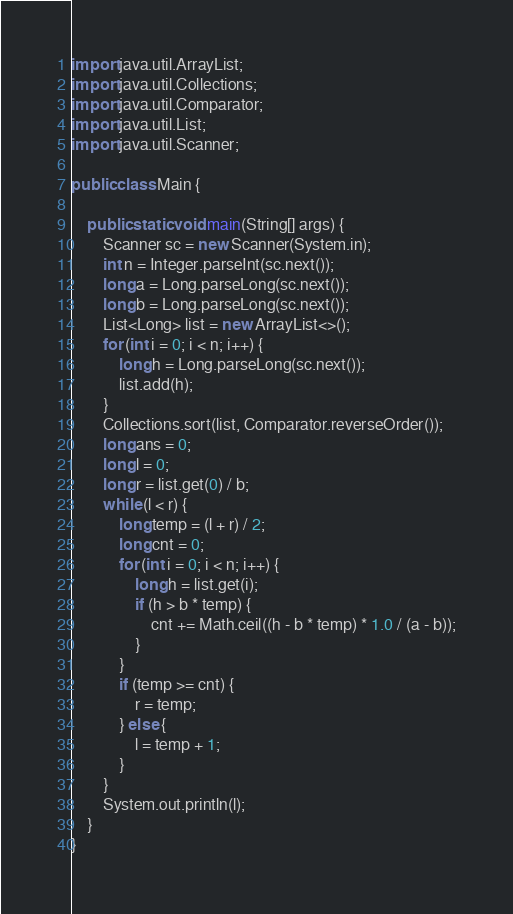Convert code to text. <code><loc_0><loc_0><loc_500><loc_500><_Java_>import java.util.ArrayList;
import java.util.Collections;
import java.util.Comparator;
import java.util.List;
import java.util.Scanner;

public class Main {

    public static void main(String[] args) {
        Scanner sc = new Scanner(System.in);
        int n = Integer.parseInt(sc.next());
        long a = Long.parseLong(sc.next());
        long b = Long.parseLong(sc.next());
        List<Long> list = new ArrayList<>();
        for (int i = 0; i < n; i++) {
            long h = Long.parseLong(sc.next());
            list.add(h);
        }
        Collections.sort(list, Comparator.reverseOrder());
        long ans = 0;
        long l = 0;
        long r = list.get(0) / b;
        while (l < r) {
            long temp = (l + r) / 2;
            long cnt = 0;
            for (int i = 0; i < n; i++) {
                long h = list.get(i);
                if (h > b * temp) {
                    cnt += Math.ceil((h - b * temp) * 1.0 / (a - b));
                }
            }
            if (temp >= cnt) {
                r = temp;
            } else {
                l = temp + 1;
            }
        }
        System.out.println(l);
    }
}</code> 